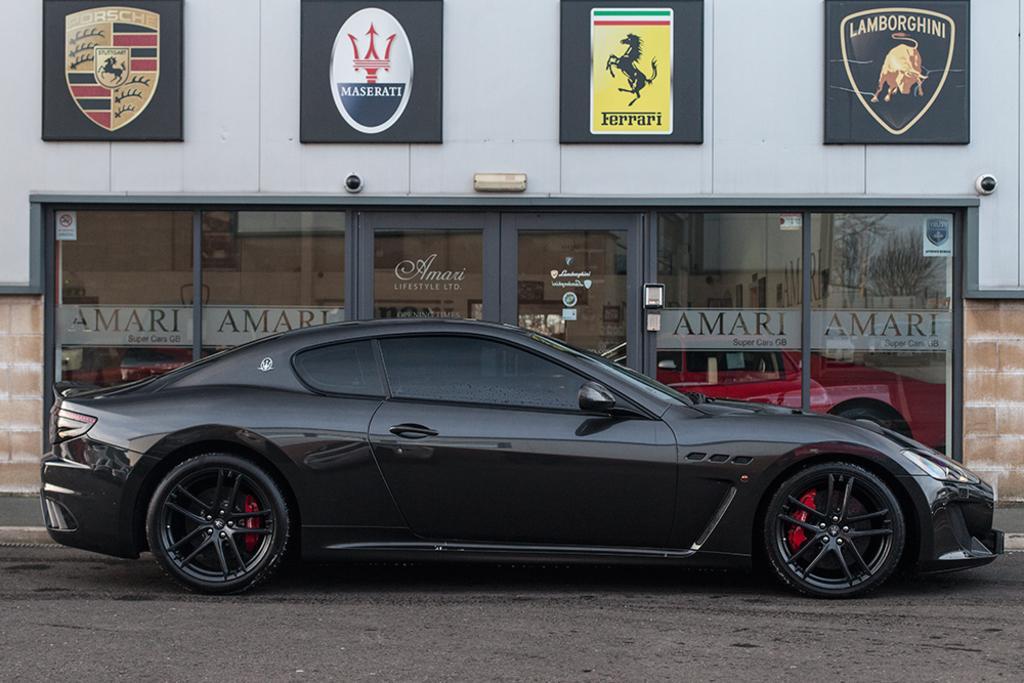How would you summarize this image in a sentence or two? In this image there is a vehicle moving on the road, behind the vehicle there is a building with glass door, on which there is some text, above the door there are a few boards with some images and text are hanging on the wall. 